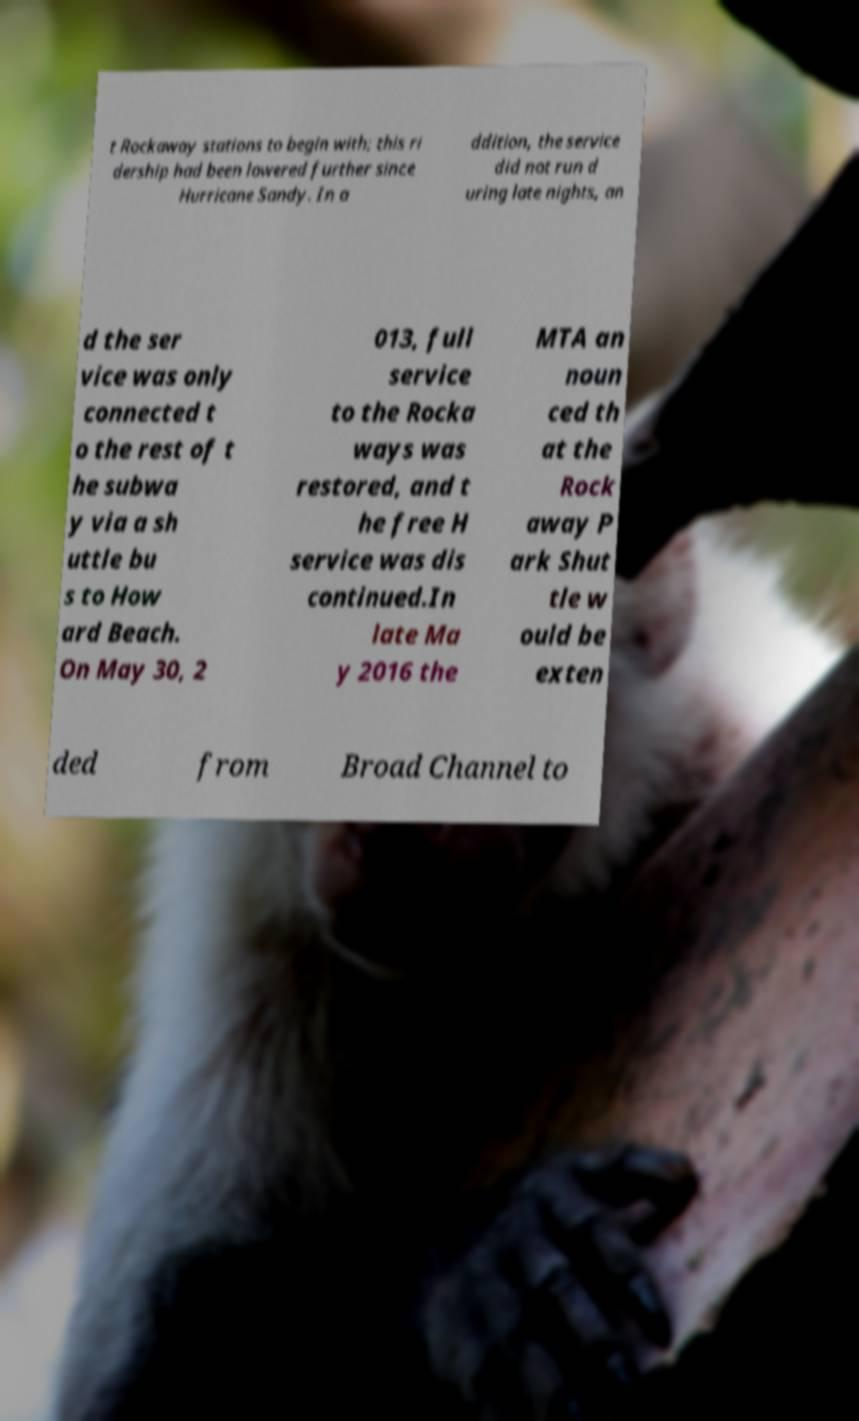What messages or text are displayed in this image? I need them in a readable, typed format. t Rockaway stations to begin with; this ri dership had been lowered further since Hurricane Sandy. In a ddition, the service did not run d uring late nights, an d the ser vice was only connected t o the rest of t he subwa y via a sh uttle bu s to How ard Beach. On May 30, 2 013, full service to the Rocka ways was restored, and t he free H service was dis continued.In late Ma y 2016 the MTA an noun ced th at the Rock away P ark Shut tle w ould be exten ded from Broad Channel to 